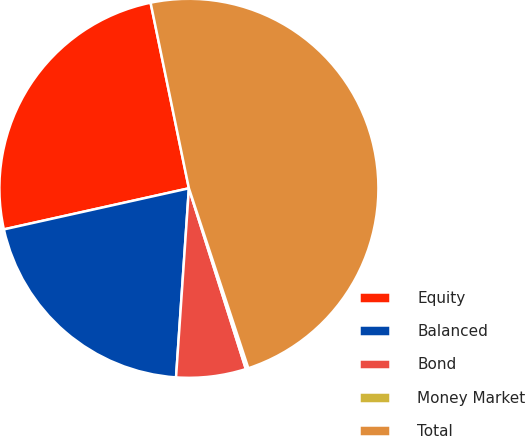Convert chart. <chart><loc_0><loc_0><loc_500><loc_500><pie_chart><fcel>Equity<fcel>Balanced<fcel>Bond<fcel>Money Market<fcel>Total<nl><fcel>25.24%<fcel>20.44%<fcel>5.94%<fcel>0.22%<fcel>48.16%<nl></chart> 